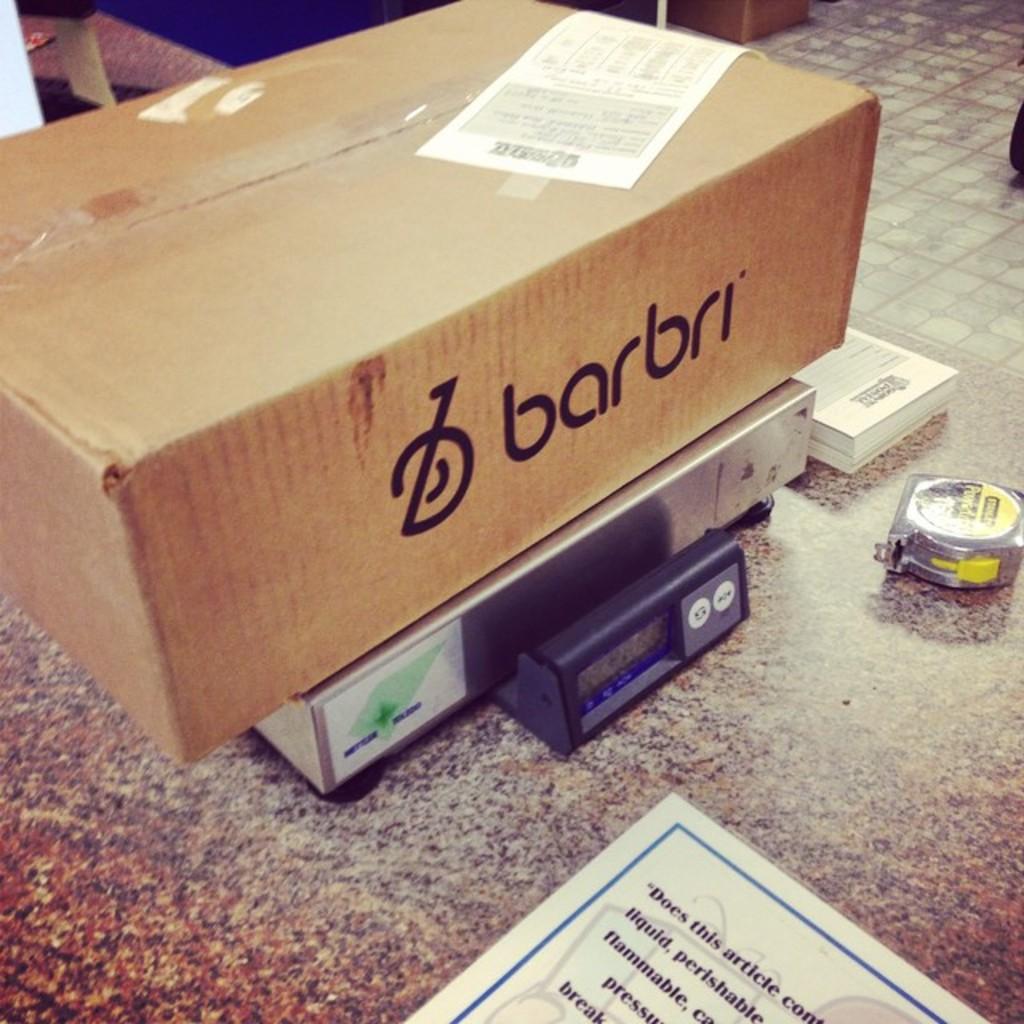What company is on the box?
Your answer should be compact. Barbri. What is the first letter shown on the box?
Offer a very short reply. B. 